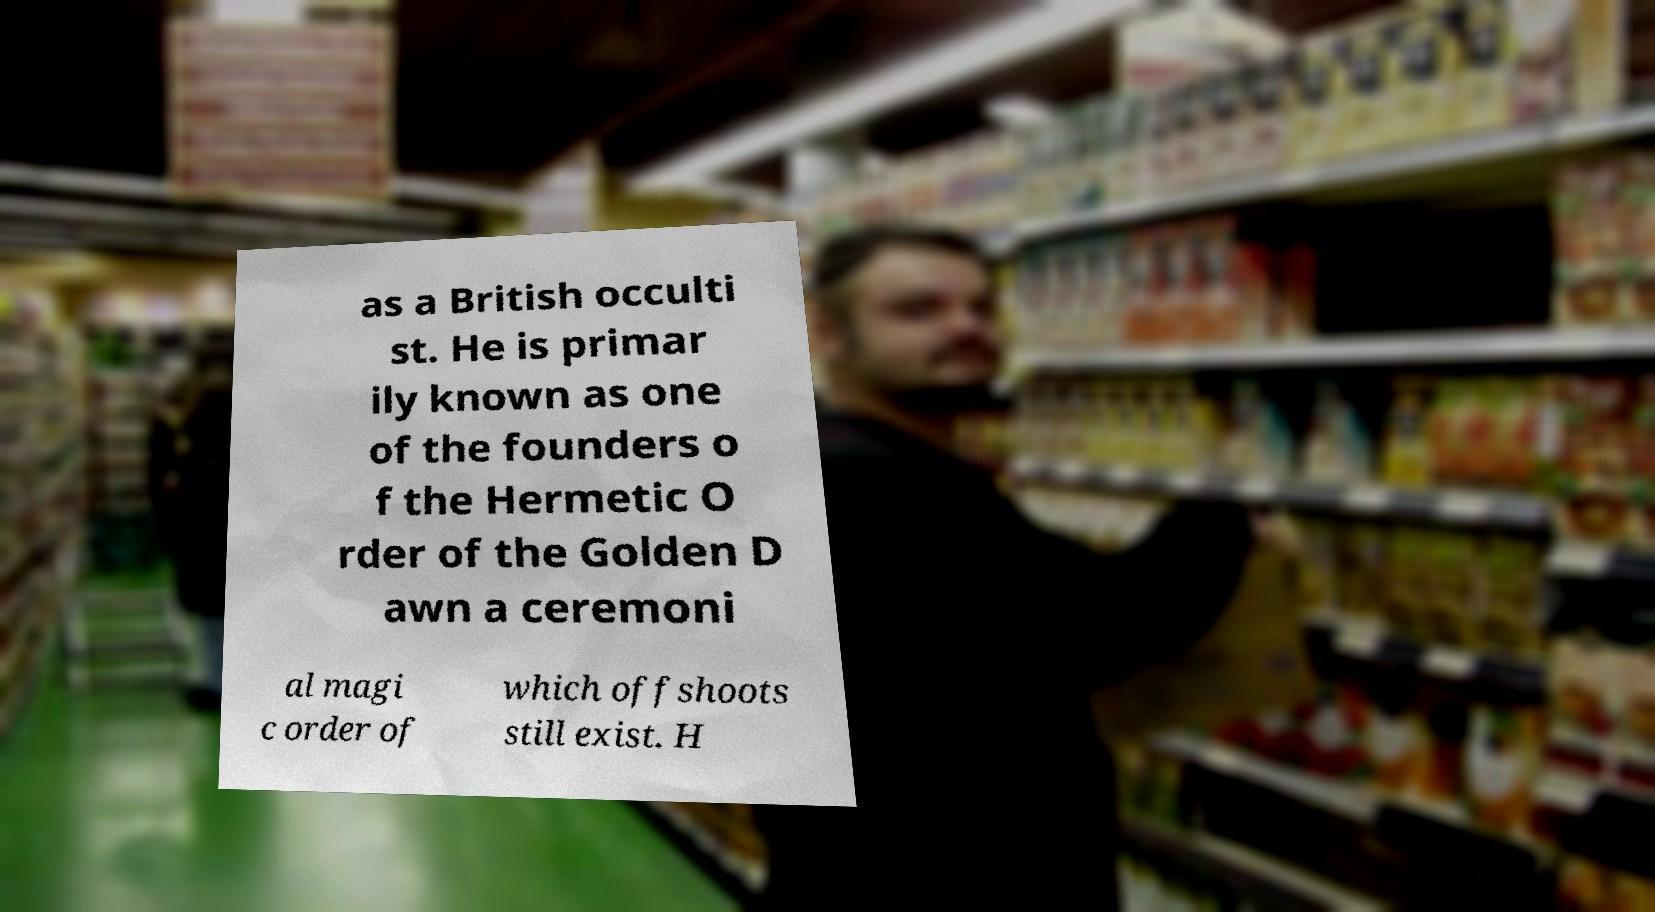Could you assist in decoding the text presented in this image and type it out clearly? as a British occulti st. He is primar ily known as one of the founders o f the Hermetic O rder of the Golden D awn a ceremoni al magi c order of which offshoots still exist. H 